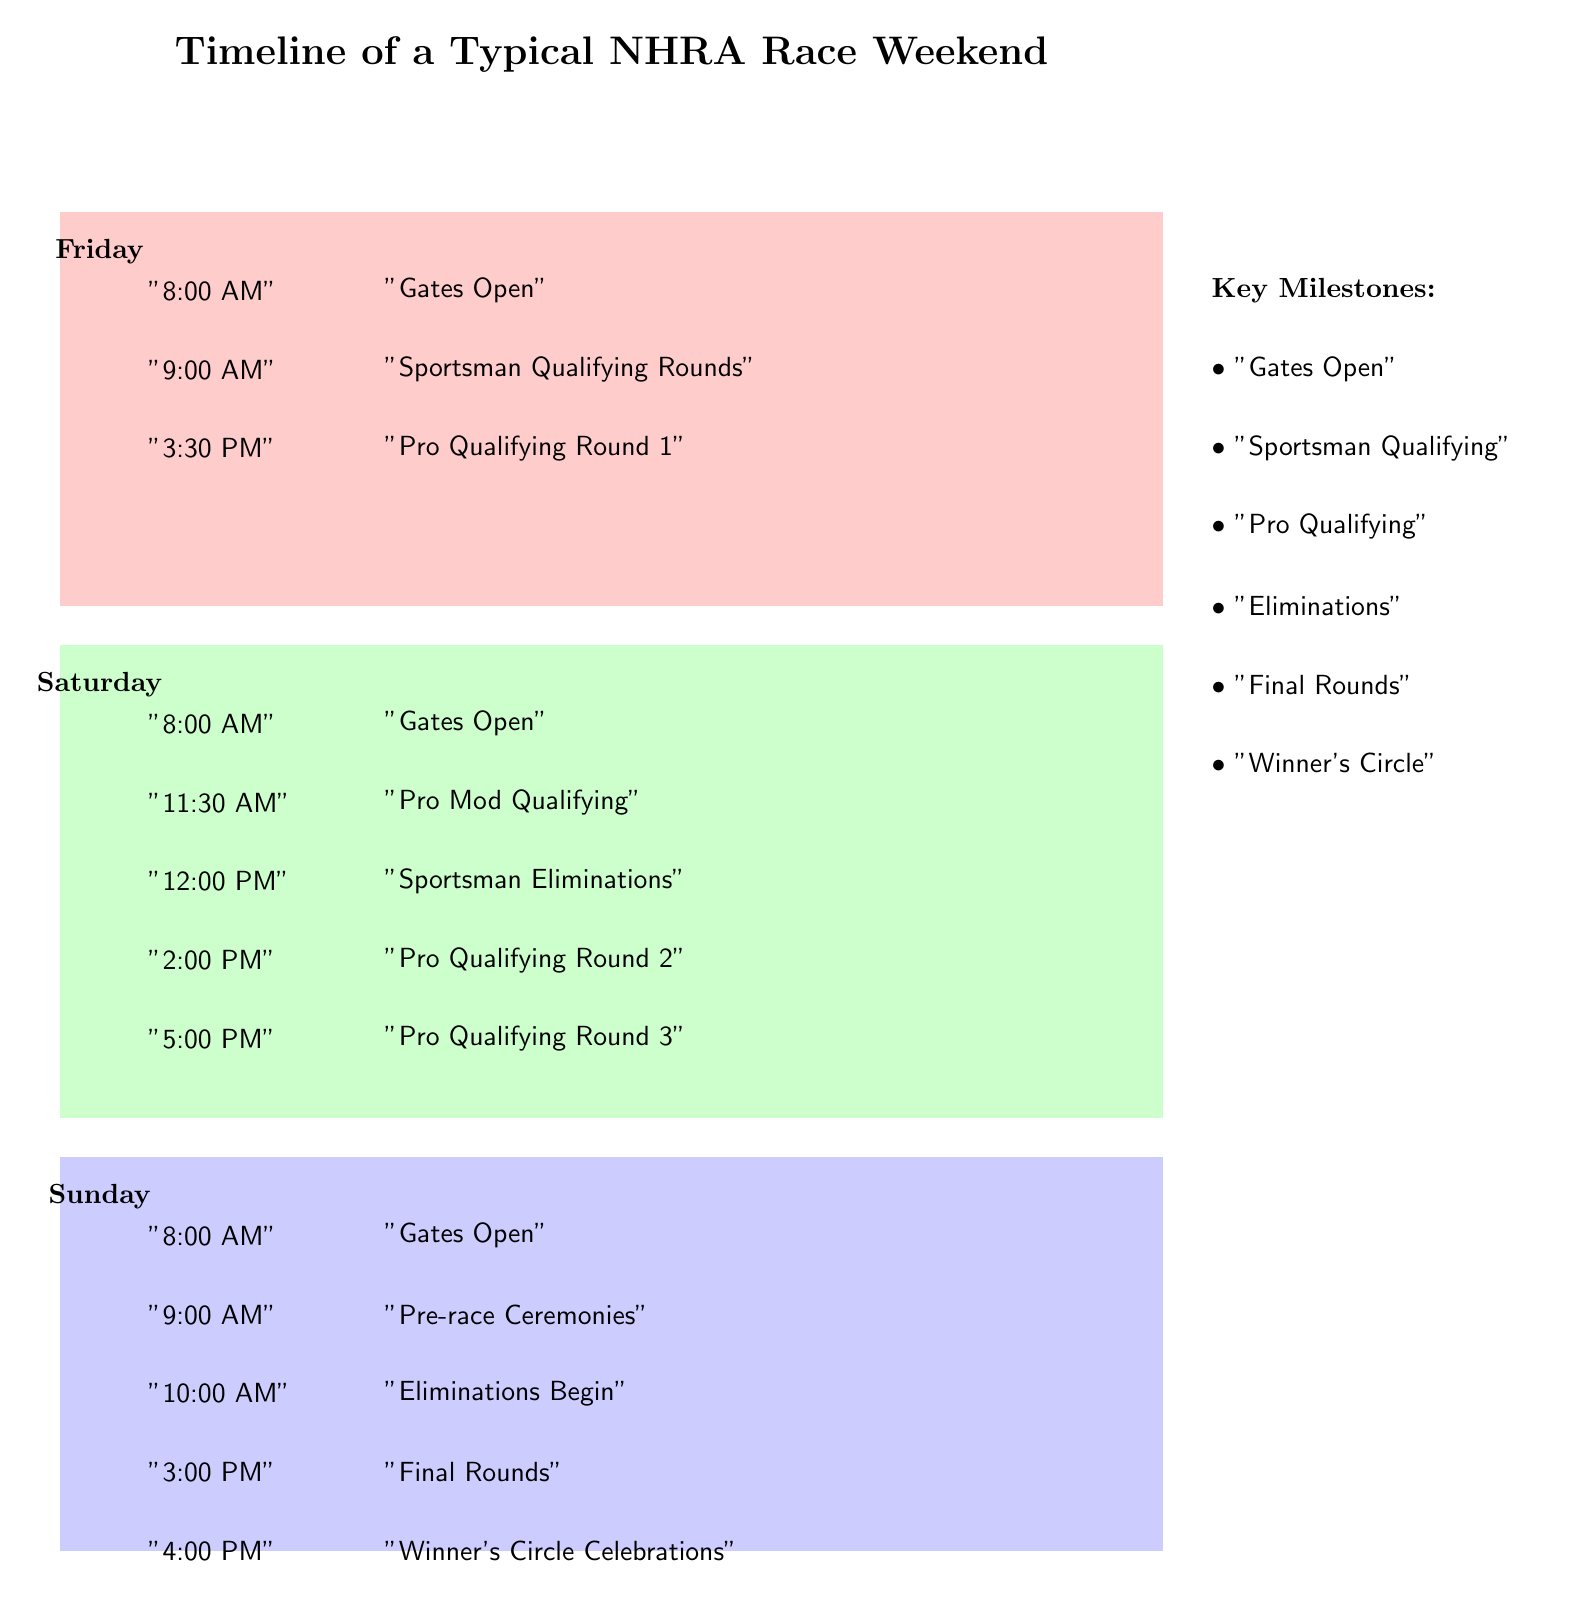What's the first event on Friday? The first event listed under Friday starts at 8:00 AM, which is when the gates open.
Answer: Gates Open What time does Pro Qualifying Round 1 start? Looking at the Friday section, Pro Qualifying Round 1 starts at 3:30 PM.
Answer: 3:30 PM How many Pro Qualifying rounds are on Saturday? The Saturday section indicates there are three Pro Qualifying rounds: Round 2 at 2:00 PM and Round 3 at 5:00 PM, in addition to the Pro Mod qualifying at 11:30 AM. In total, this is three events.
Answer: 3 Which day has the pre-race ceremonies? In the Sunday section, it clearly states the pre-race ceremonies occur at 9:00 AM.
Answer: Sunday What is the last event on Sunday? The last event listed on Sunday occurs at 4:00 PM, which is the winner's circle celebrations.
Answer: Winner's Circle Celebrations Which key milestone occurs after eliminations? According to the key milestones section, after eliminations, the next milestone is the final rounds.
Answer: Final Rounds What is the time difference between Gates Open on Friday and Sunday? Gates Open on Friday is at 8:00 AM and on Sunday it is also at 8:00 AM. Therefore, there is no time difference—both open at the same time.
Answer: No difference How many events occur before 12:00 PM on Saturday? Looking at the Saturday events, there are two that occur before 12:00 PM: Gates Open at 8:00 AM and Pro Mod Qualifying at 11:30 AM.
Answer: 2 What is the key milestone associated with the 3:00 PM event on Sunday? The 3:00 PM event on Sunday relates to the final rounds, which is one of the key milestones listed.
Answer: Final Rounds 